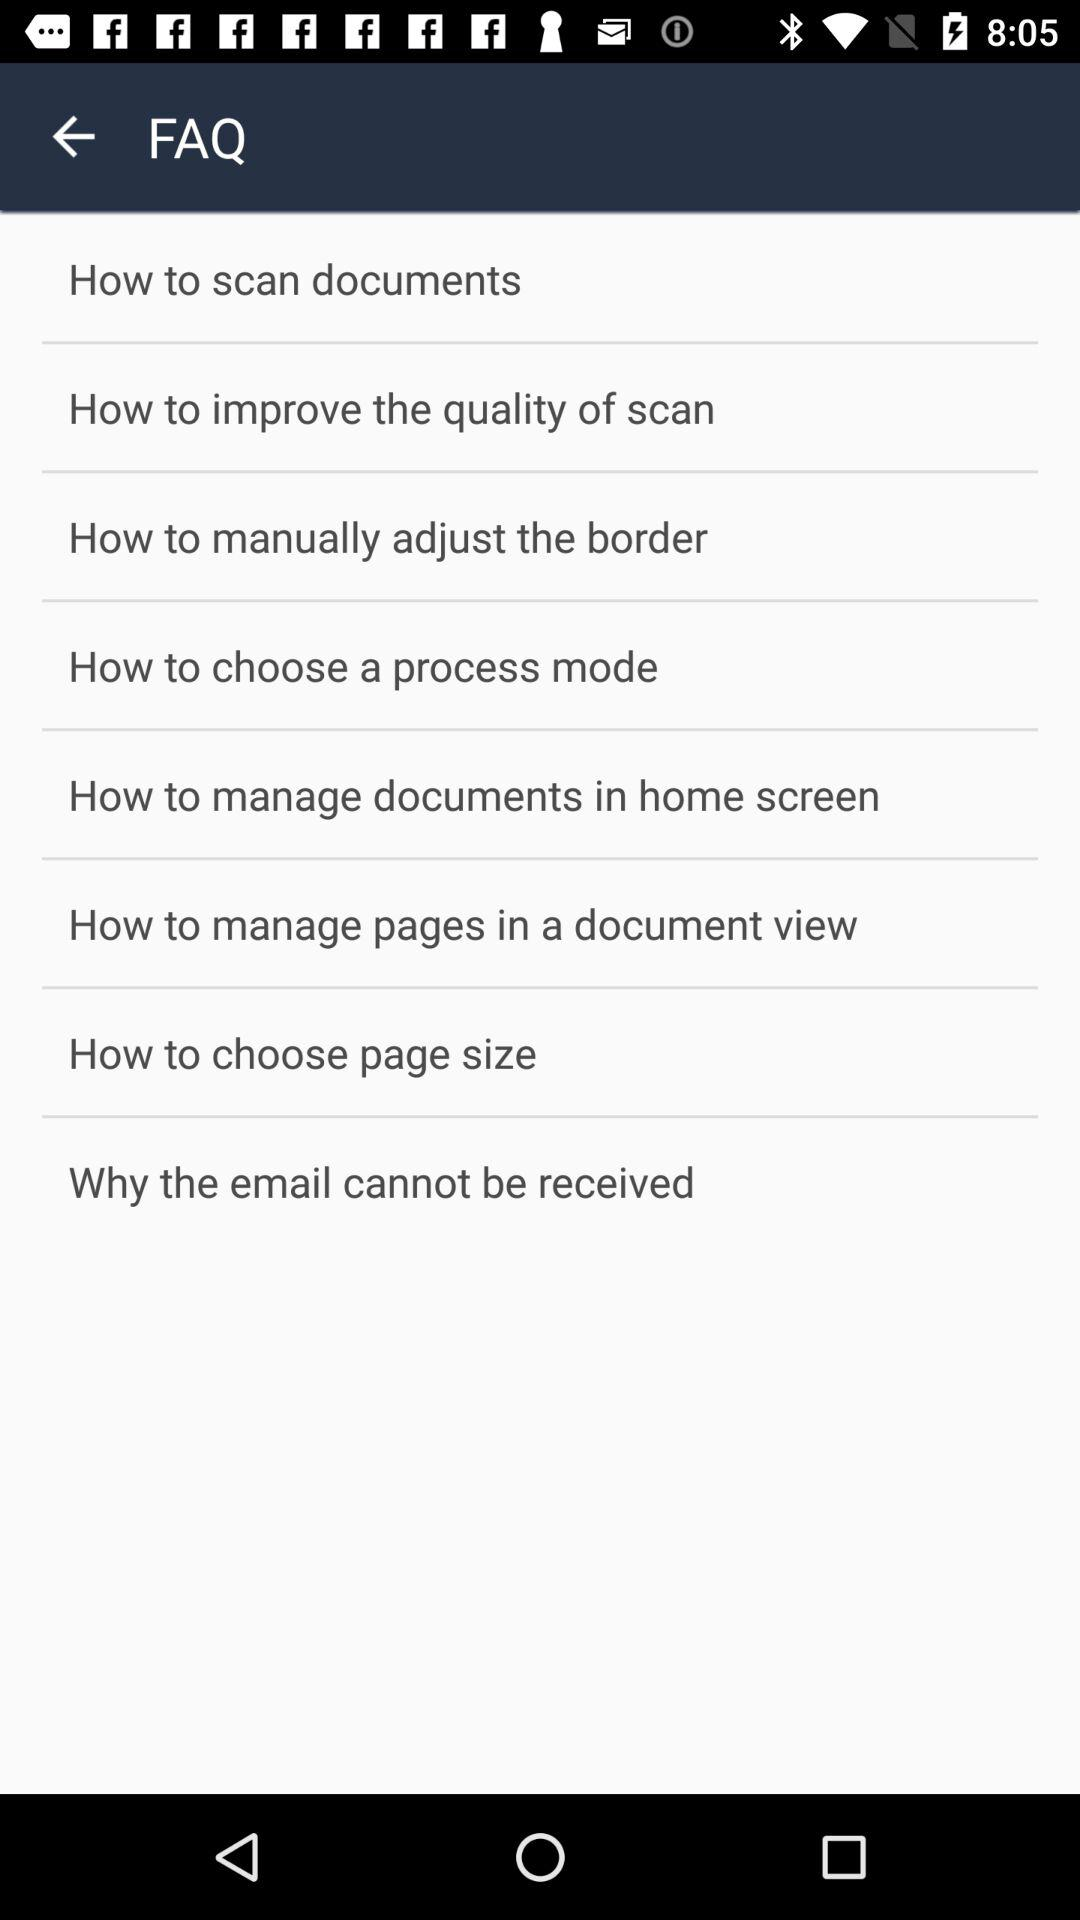How many FAQs are there on this page that are about improving the quality of scans?
Answer the question using a single word or phrase. 1 